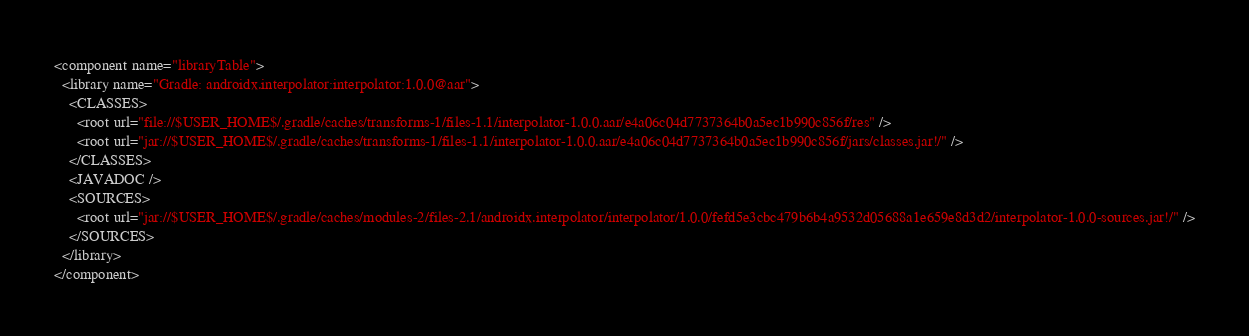<code> <loc_0><loc_0><loc_500><loc_500><_XML_><component name="libraryTable">
  <library name="Gradle: androidx.interpolator:interpolator:1.0.0@aar">
    <CLASSES>
      <root url="file://$USER_HOME$/.gradle/caches/transforms-1/files-1.1/interpolator-1.0.0.aar/e4a06c04d7737364b0a5ec1b990c856f/res" />
      <root url="jar://$USER_HOME$/.gradle/caches/transforms-1/files-1.1/interpolator-1.0.0.aar/e4a06c04d7737364b0a5ec1b990c856f/jars/classes.jar!/" />
    </CLASSES>
    <JAVADOC />
    <SOURCES>
      <root url="jar://$USER_HOME$/.gradle/caches/modules-2/files-2.1/androidx.interpolator/interpolator/1.0.0/fefd5e3cbc479b6b4a9532d05688a1e659e8d3d2/interpolator-1.0.0-sources.jar!/" />
    </SOURCES>
  </library>
</component></code> 